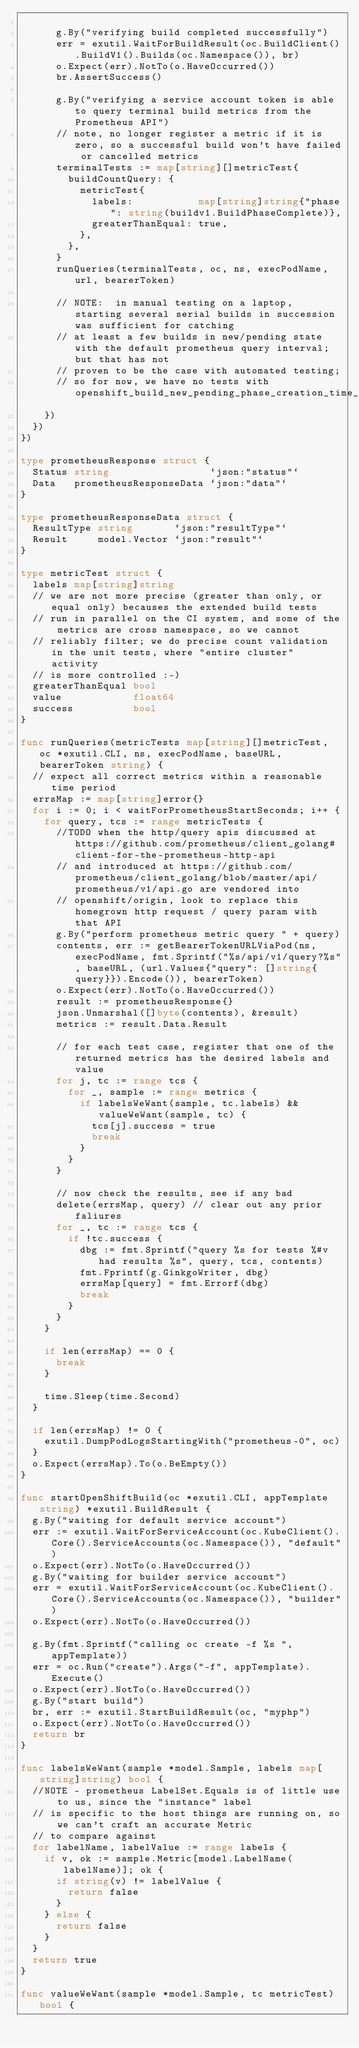<code> <loc_0><loc_0><loc_500><loc_500><_Go_>
			g.By("verifying build completed successfully")
			err = exutil.WaitForBuildResult(oc.BuildClient().BuildV1().Builds(oc.Namespace()), br)
			o.Expect(err).NotTo(o.HaveOccurred())
			br.AssertSuccess()

			g.By("verifying a service account token is able to query terminal build metrics from the Prometheus API")
			// note, no longer register a metric if it is zero, so a successful build won't have failed or cancelled metrics
			terminalTests := map[string][]metricTest{
				buildCountQuery: {
					metricTest{
						labels:           map[string]string{"phase": string(buildv1.BuildPhaseComplete)},
						greaterThanEqual: true,
					},
				},
			}
			runQueries(terminalTests, oc, ns, execPodName, url, bearerToken)

			// NOTE:  in manual testing on a laptop, starting several serial builds in succession was sufficient for catching
			// at least a few builds in new/pending state with the default prometheus query interval;  but that has not
			// proven to be the case with automated testing;
			// so for now, we have no tests with openshift_build_new_pending_phase_creation_time_seconds
		})
	})
})

type prometheusResponse struct {
	Status string                 `json:"status"`
	Data   prometheusResponseData `json:"data"`
}

type prometheusResponseData struct {
	ResultType string       `json:"resultType"`
	Result     model.Vector `json:"result"`
}

type metricTest struct {
	labels map[string]string
	// we are not more precise (greater than only, or equal only) becauses the extended build tests
	// run in parallel on the CI system, and some of the metrics are cross namespace, so we cannot
	// reliably filter; we do precise count validation in the unit tests, where "entire cluster" activity
	// is more controlled :-)
	greaterThanEqual bool
	value            float64
	success          bool
}

func runQueries(metricTests map[string][]metricTest, oc *exutil.CLI, ns, execPodName, baseURL, bearerToken string) {
	// expect all correct metrics within a reasonable time period
	errsMap := map[string]error{}
	for i := 0; i < waitForPrometheusStartSeconds; i++ {
		for query, tcs := range metricTests {
			//TODO when the http/query apis discussed at https://github.com/prometheus/client_golang#client-for-the-prometheus-http-api
			// and introduced at https://github.com/prometheus/client_golang/blob/master/api/prometheus/v1/api.go are vendored into
			// openshift/origin, look to replace this homegrown http request / query param with that API
			g.By("perform prometheus metric query " + query)
			contents, err := getBearerTokenURLViaPod(ns, execPodName, fmt.Sprintf("%s/api/v1/query?%s", baseURL, (url.Values{"query": []string{query}}).Encode()), bearerToken)
			o.Expect(err).NotTo(o.HaveOccurred())
			result := prometheusResponse{}
			json.Unmarshal([]byte(contents), &result)
			metrics := result.Data.Result

			// for each test case, register that one of the returned metrics has the desired labels and value
			for j, tc := range tcs {
				for _, sample := range metrics {
					if labelsWeWant(sample, tc.labels) && valueWeWant(sample, tc) {
						tcs[j].success = true
						break
					}
				}
			}

			// now check the results, see if any bad
			delete(errsMap, query) // clear out any prior faliures
			for _, tc := range tcs {
				if !tc.success {
					dbg := fmt.Sprintf("query %s for tests %#v had results %s", query, tcs, contents)
					fmt.Fprintf(g.GinkgoWriter, dbg)
					errsMap[query] = fmt.Errorf(dbg)
					break
				}
			}
		}

		if len(errsMap) == 0 {
			break
		}

		time.Sleep(time.Second)
	}

	if len(errsMap) != 0 {
		exutil.DumpPodLogsStartingWith("prometheus-0", oc)
	}
	o.Expect(errsMap).To(o.BeEmpty())
}

func startOpenShiftBuild(oc *exutil.CLI, appTemplate string) *exutil.BuildResult {
	g.By("waiting for default service account")
	err := exutil.WaitForServiceAccount(oc.KubeClient().Core().ServiceAccounts(oc.Namespace()), "default")
	o.Expect(err).NotTo(o.HaveOccurred())
	g.By("waiting for builder service account")
	err = exutil.WaitForServiceAccount(oc.KubeClient().Core().ServiceAccounts(oc.Namespace()), "builder")
	o.Expect(err).NotTo(o.HaveOccurred())

	g.By(fmt.Sprintf("calling oc create -f %s ", appTemplate))
	err = oc.Run("create").Args("-f", appTemplate).Execute()
	o.Expect(err).NotTo(o.HaveOccurred())
	g.By("start build")
	br, err := exutil.StartBuildResult(oc, "myphp")
	o.Expect(err).NotTo(o.HaveOccurred())
	return br
}

func labelsWeWant(sample *model.Sample, labels map[string]string) bool {
	//NOTE - prometheus LabelSet.Equals is of little use to us, since the "instance" label
	// is specific to the host things are running on, so we can't craft an accurate Metric
	// to compare against
	for labelName, labelValue := range labels {
		if v, ok := sample.Metric[model.LabelName(labelName)]; ok {
			if string(v) != labelValue {
				return false
			}
		} else {
			return false
		}
	}
	return true
}

func valueWeWant(sample *model.Sample, tc metricTest) bool {</code> 